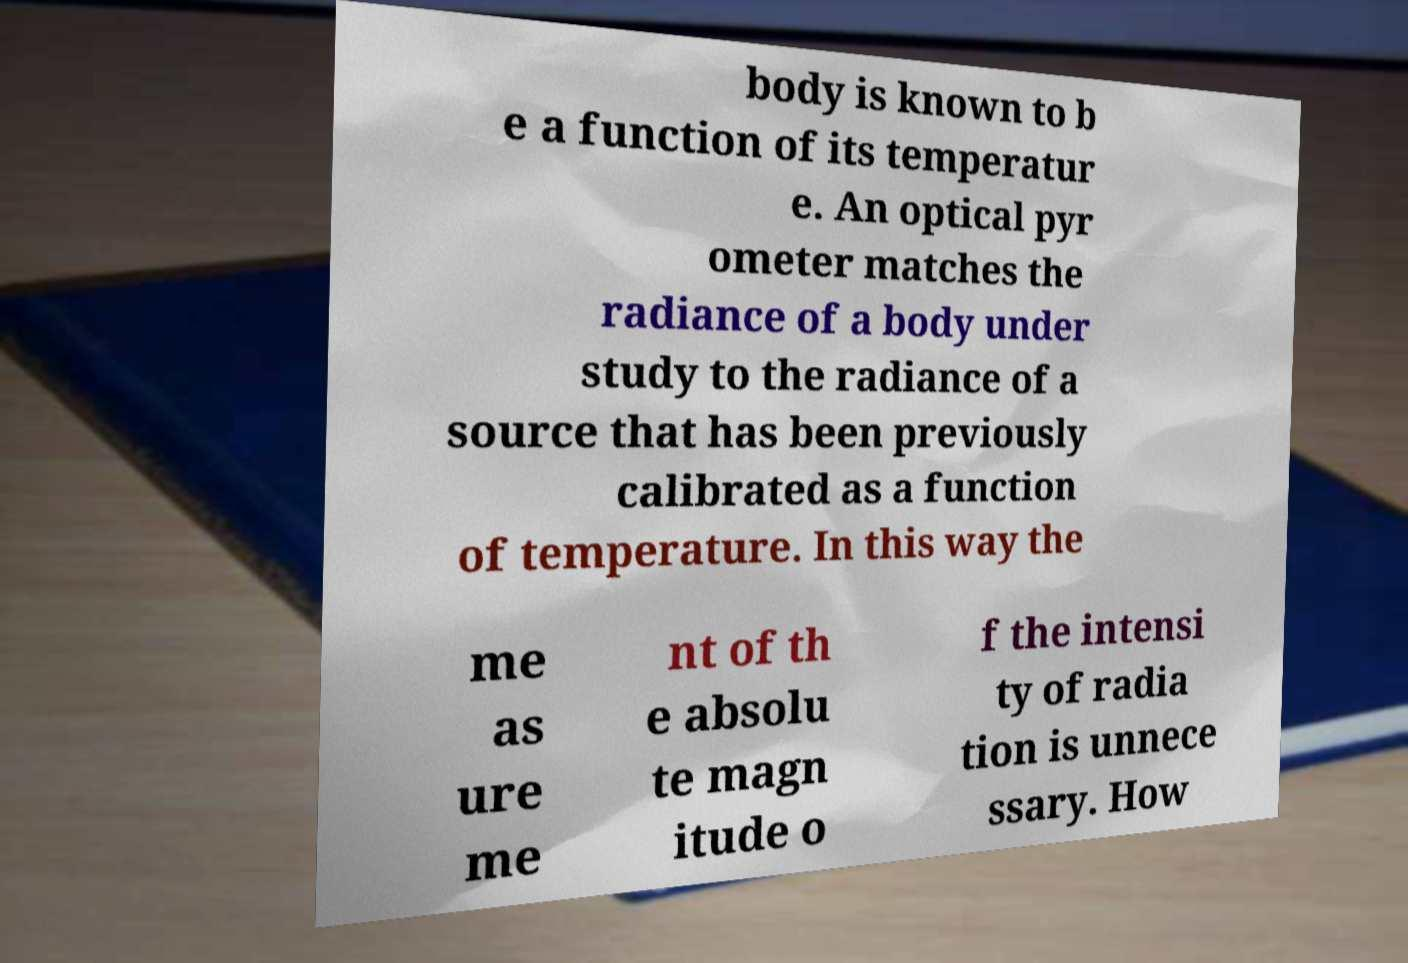Could you assist in decoding the text presented in this image and type it out clearly? body is known to b e a function of its temperatur e. An optical pyr ometer matches the radiance of a body under study to the radiance of a source that has been previously calibrated as a function of temperature. In this way the me as ure me nt of th e absolu te magn itude o f the intensi ty of radia tion is unnece ssary. How 